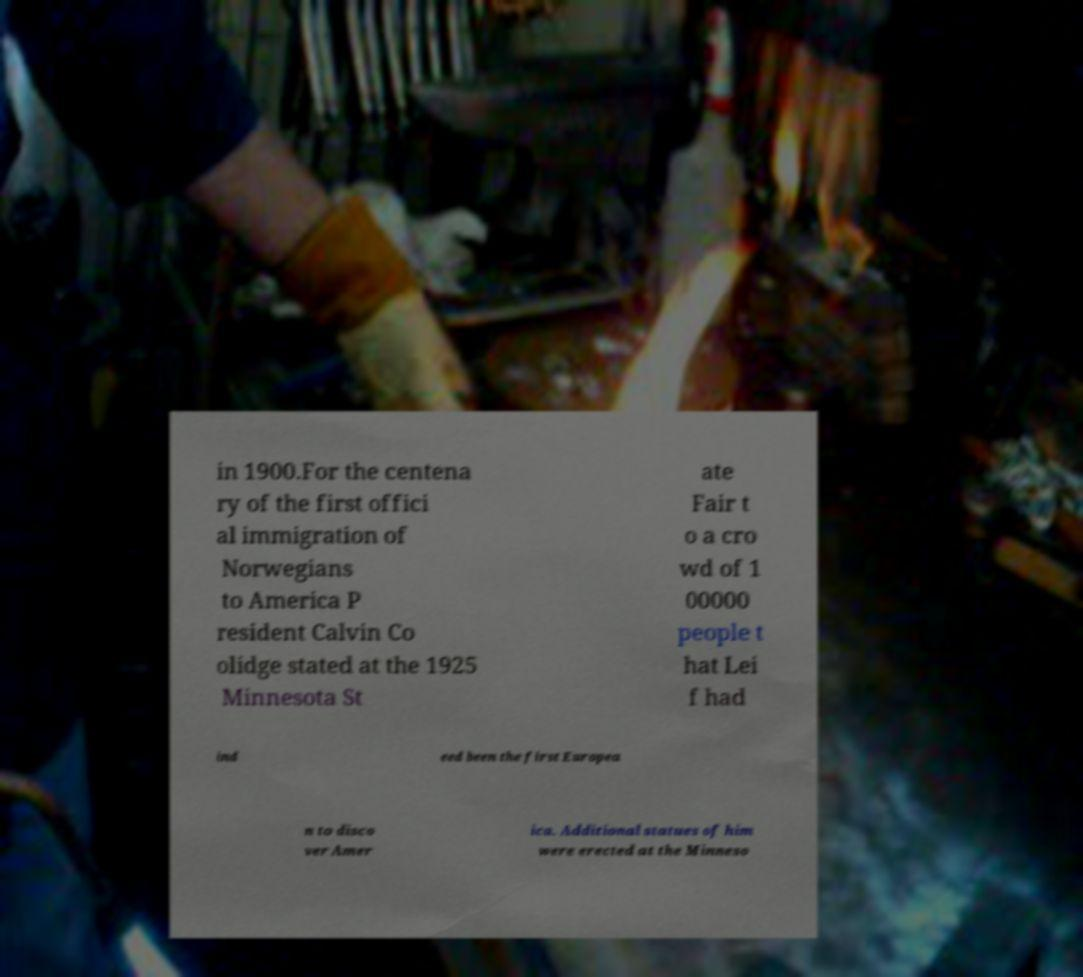Could you assist in decoding the text presented in this image and type it out clearly? in 1900.For the centena ry of the first offici al immigration of Norwegians to America P resident Calvin Co olidge stated at the 1925 Minnesota St ate Fair t o a cro wd of 1 00000 people t hat Lei f had ind eed been the first Europea n to disco ver Amer ica. Additional statues of him were erected at the Minneso 